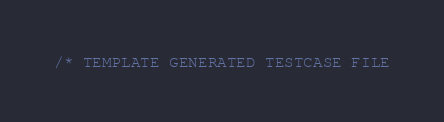<code> <loc_0><loc_0><loc_500><loc_500><_C++_>/* TEMPLATE GENERATED TESTCASE FILE</code> 